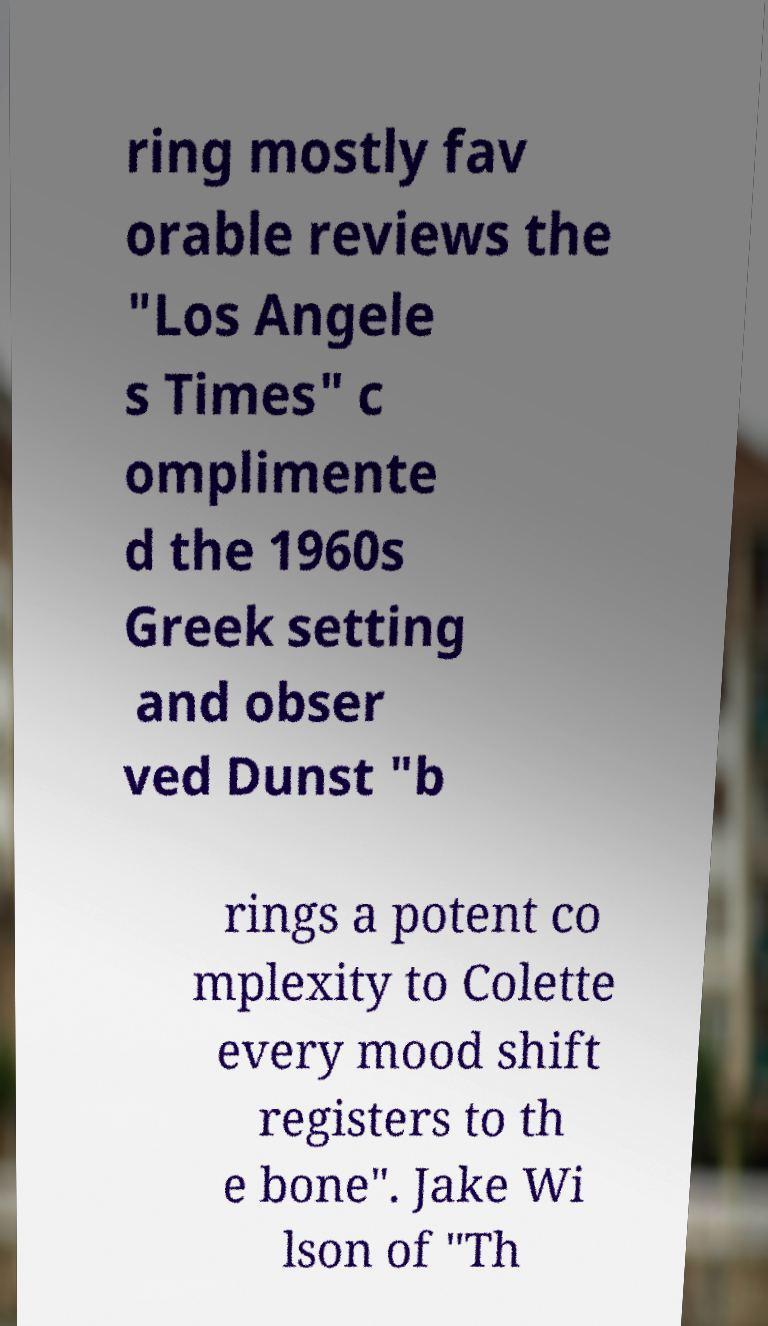Please identify and transcribe the text found in this image. ring mostly fav orable reviews the "Los Angele s Times" c omplimente d the 1960s Greek setting and obser ved Dunst "b rings a potent co mplexity to Colette every mood shift registers to th e bone". Jake Wi lson of "Th 